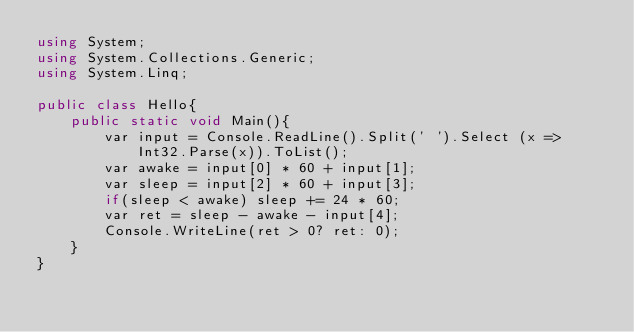Convert code to text. <code><loc_0><loc_0><loc_500><loc_500><_C#_>using System;
using System.Collections.Generic;
using System.Linq;

public class Hello{
    public static void Main(){
        var input = Console.ReadLine().Split(' ').Select (x => Int32.Parse(x)).ToList();
        var awake = input[0] * 60 + input[1];
        var sleep = input[2] * 60 + input[3];
        if(sleep < awake) sleep += 24 * 60;
        var ret = sleep - awake - input[4];
        Console.WriteLine(ret > 0? ret: 0);
    }
}
</code> 